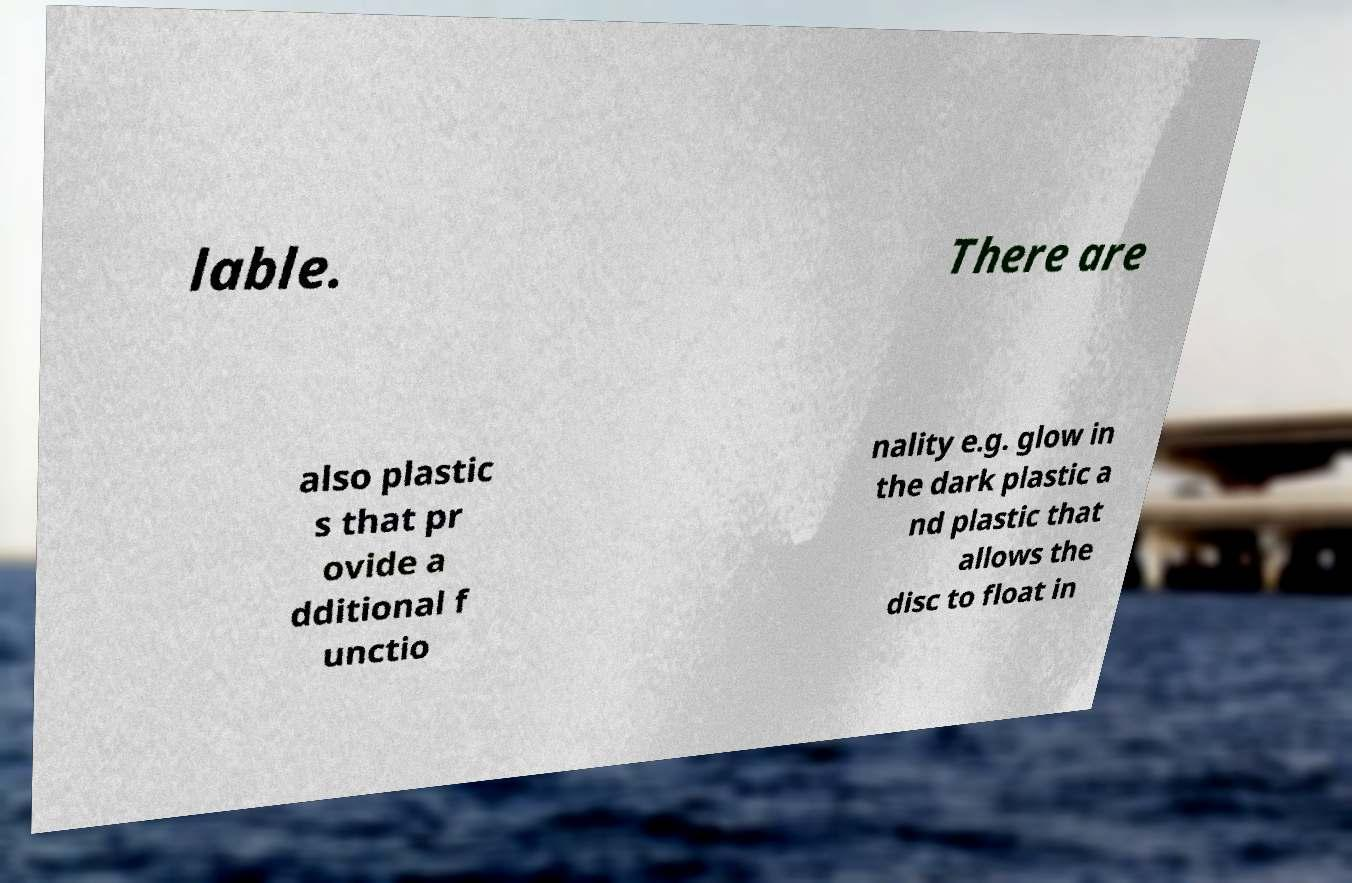Please read and relay the text visible in this image. What does it say? lable. There are also plastic s that pr ovide a dditional f unctio nality e.g. glow in the dark plastic a nd plastic that allows the disc to float in 